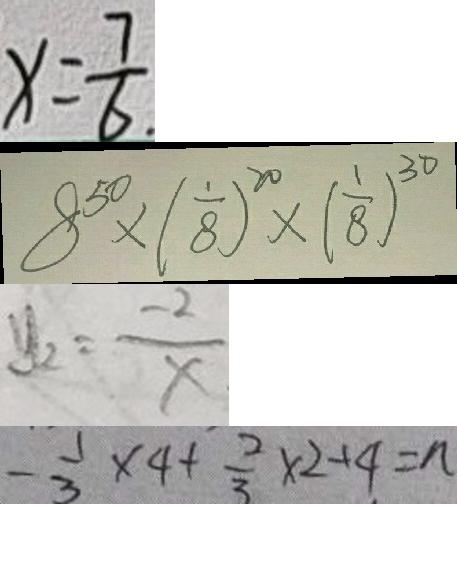<formula> <loc_0><loc_0><loc_500><loc_500>x = \frac { 7 } { 6 } . 
 8 ^ { 5 0 } \times ( \frac { 1 } { 8 } ) ^ { 2 0 } \times ( \frac { 1 } { 8 } ) ^ { 3 0 } 
 y _ { 2 } = \frac { - 2 } { x } 
 - \frac { 1 } { 3 } \times 4 + \frac { 2 } { 3 } \times 2 + 4 = n</formula> 